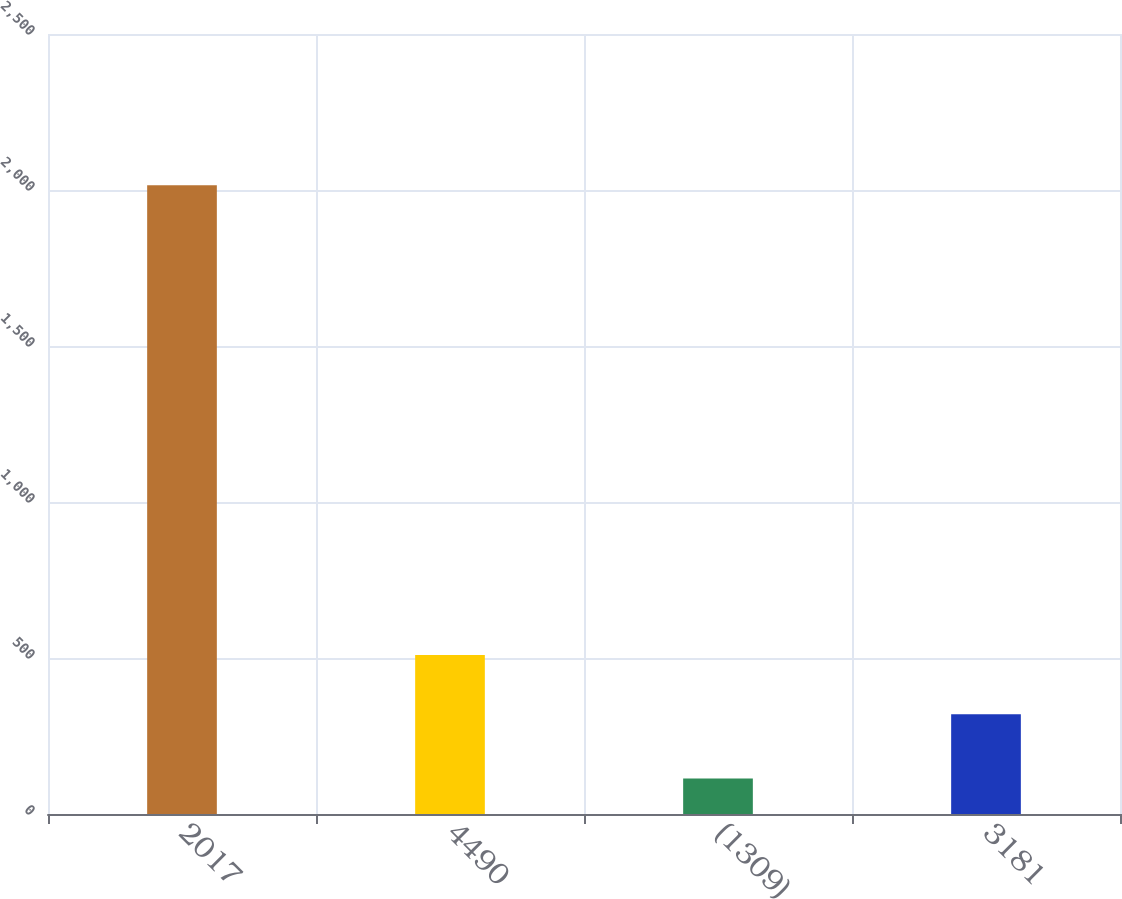Convert chart. <chart><loc_0><loc_0><loc_500><loc_500><bar_chart><fcel>2017<fcel>4490<fcel>(1309)<fcel>3181<nl><fcel>2015<fcel>509.75<fcel>113.5<fcel>319.6<nl></chart> 